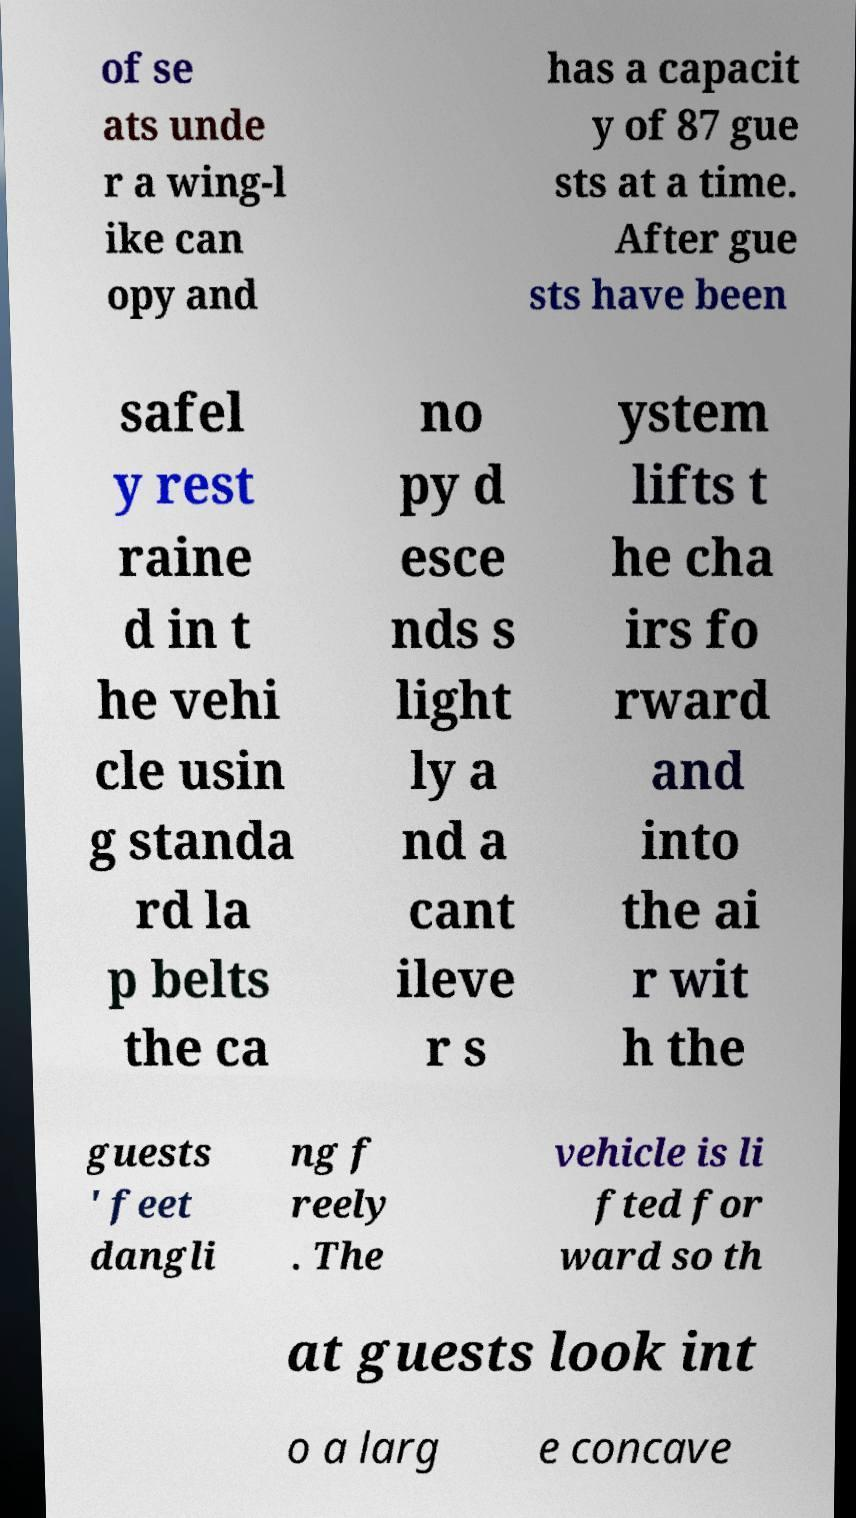What messages or text are displayed in this image? I need them in a readable, typed format. of se ats unde r a wing-l ike can opy and has a capacit y of 87 gue sts at a time. After gue sts have been safel y rest raine d in t he vehi cle usin g standa rd la p belts the ca no py d esce nds s light ly a nd a cant ileve r s ystem lifts t he cha irs fo rward and into the ai r wit h the guests ' feet dangli ng f reely . The vehicle is li fted for ward so th at guests look int o a larg e concave 